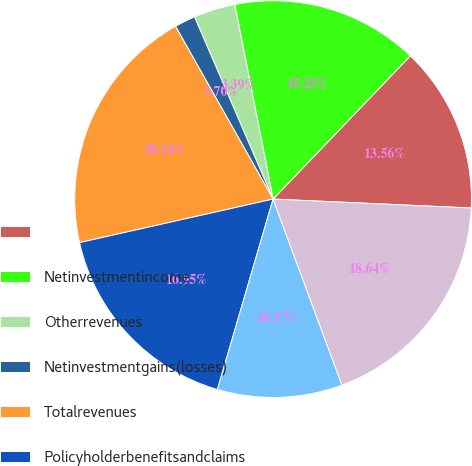Convert chart to OTSL. <chart><loc_0><loc_0><loc_500><loc_500><pie_chart><ecel><fcel>Netinvestmentincome<fcel>Otherrevenues<fcel>Netinvestmentgains(losses)<fcel>Totalrevenues<fcel>Policyholderbenefitsandclaims<fcel>Otherexpenses<fcel>Totalexpenses<nl><fcel>13.56%<fcel>15.25%<fcel>3.39%<fcel>1.7%<fcel>20.34%<fcel>16.95%<fcel>10.17%<fcel>18.64%<nl></chart> 